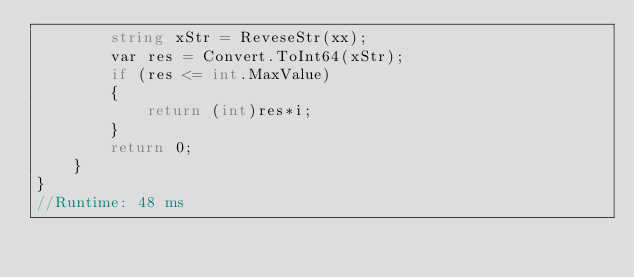Convert code to text. <code><loc_0><loc_0><loc_500><loc_500><_C#_>		string xStr = ReveseStr(xx);
		var res = Convert.ToInt64(xStr);
		if (res <= int.MaxValue)
		{
			return (int)res*i;
		}
		return 0;
	}
}
//Runtime: 48 ms</code> 